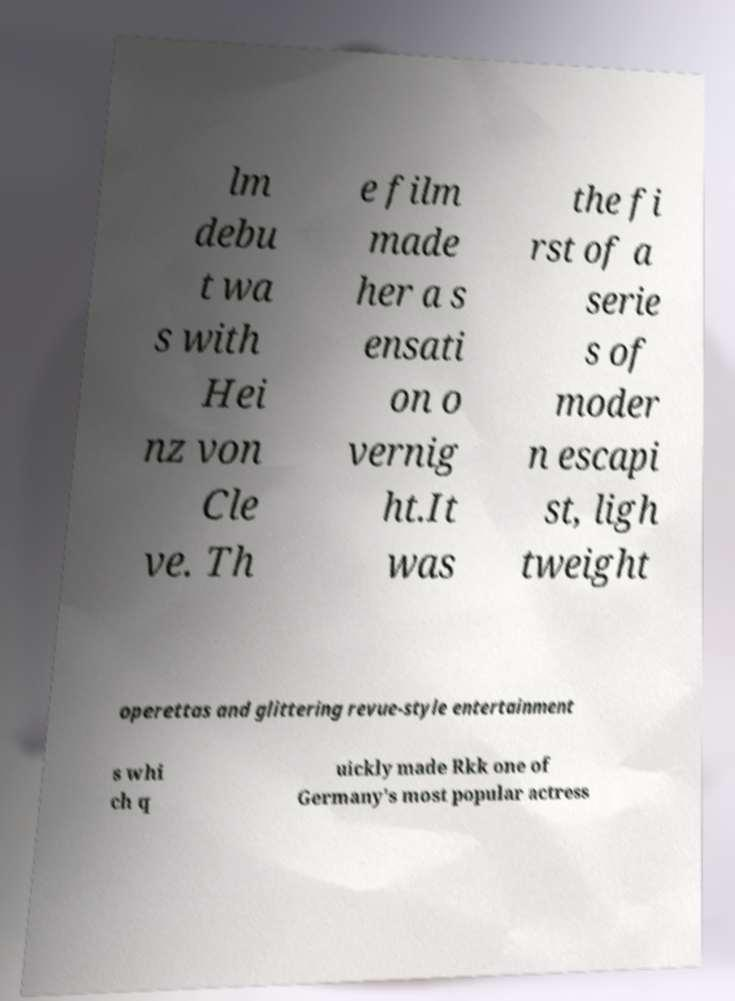I need the written content from this picture converted into text. Can you do that? lm debu t wa s with Hei nz von Cle ve. Th e film made her a s ensati on o vernig ht.It was the fi rst of a serie s of moder n escapi st, ligh tweight operettas and glittering revue-style entertainment s whi ch q uickly made Rkk one of Germany's most popular actress 